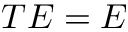<formula> <loc_0><loc_0><loc_500><loc_500>T E = E</formula> 